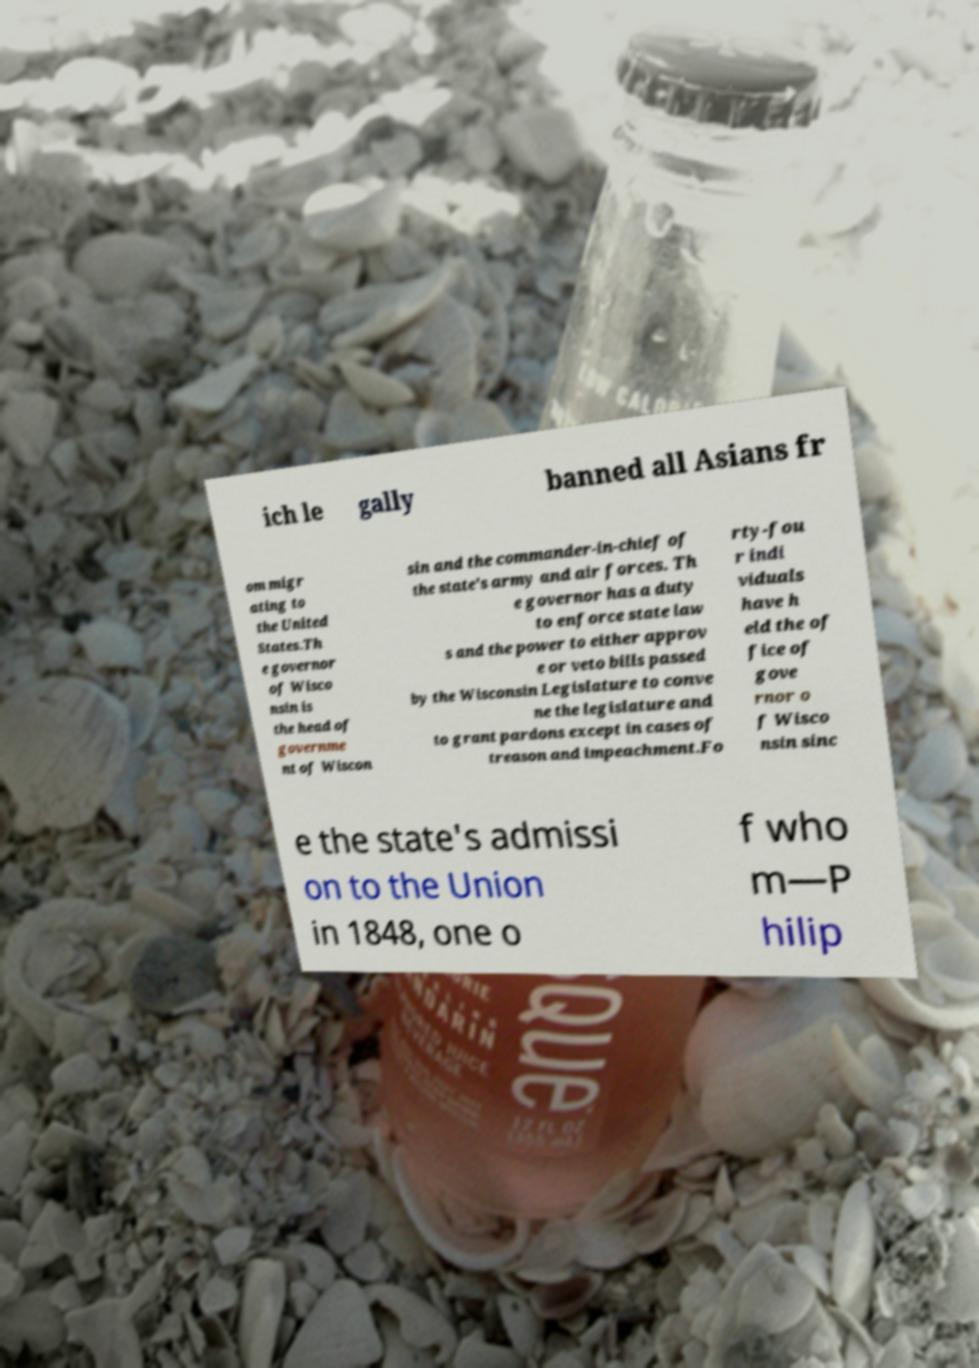For documentation purposes, I need the text within this image transcribed. Could you provide that? ich le gally banned all Asians fr om migr ating to the United States.Th e governor of Wisco nsin is the head of governme nt of Wiscon sin and the commander-in-chief of the state's army and air forces. Th e governor has a duty to enforce state law s and the power to either approv e or veto bills passed by the Wisconsin Legislature to conve ne the legislature and to grant pardons except in cases of treason and impeachment.Fo rty-fou r indi viduals have h eld the of fice of gove rnor o f Wisco nsin sinc e the state's admissi on to the Union in 1848, one o f who m—P hilip 